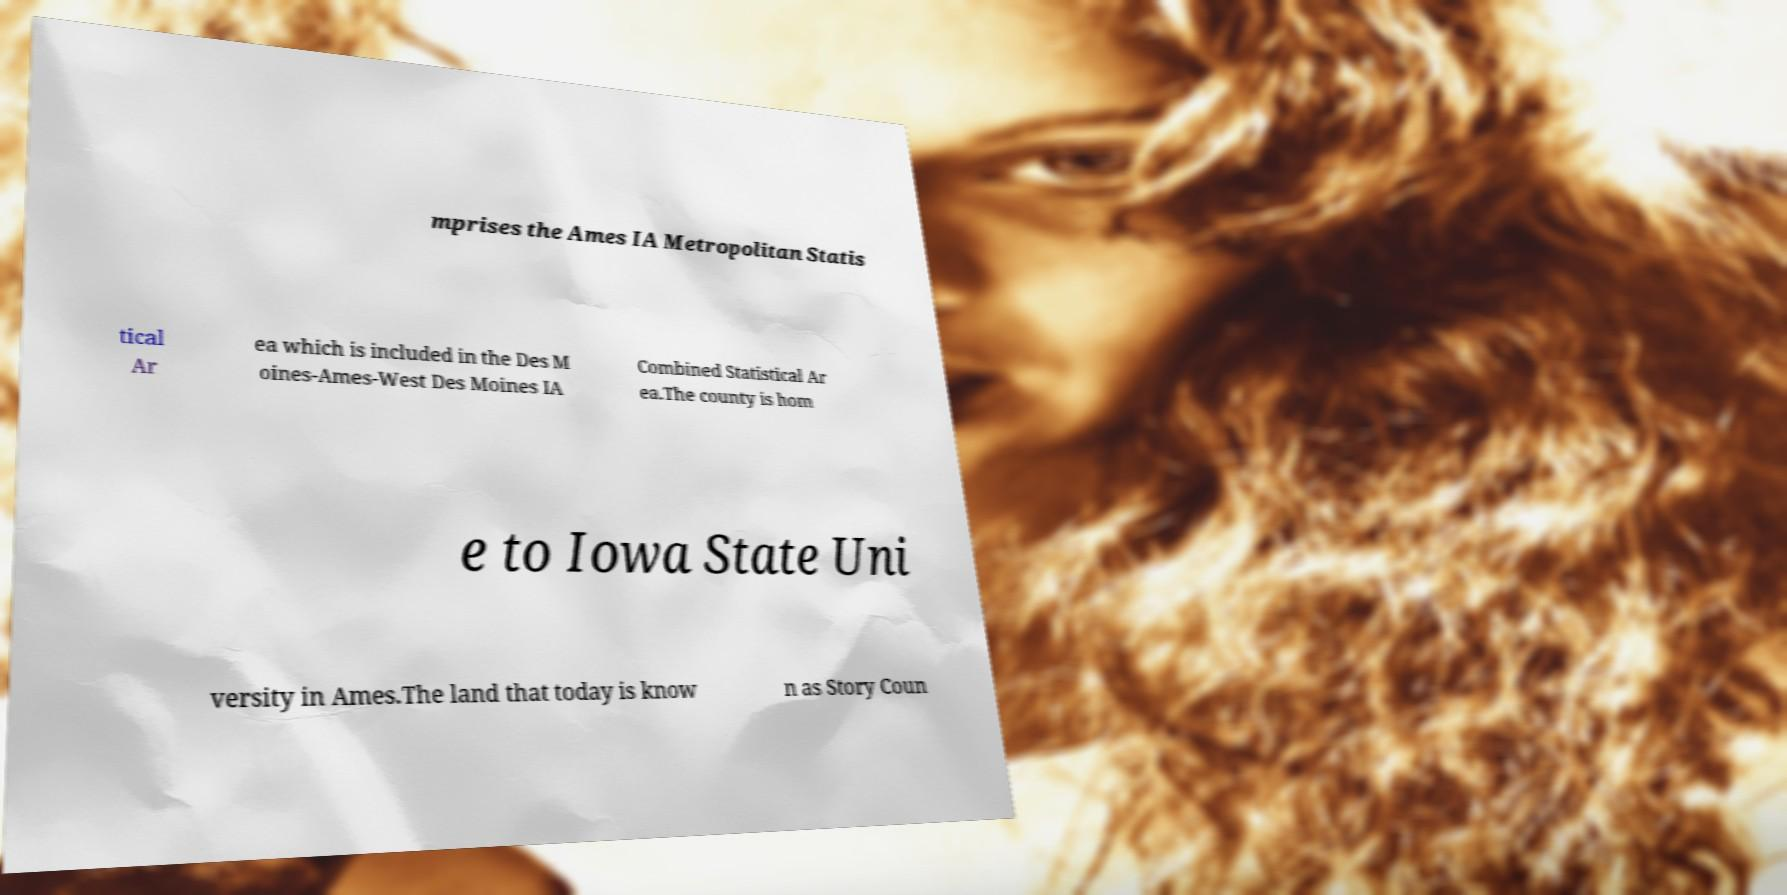Can you accurately transcribe the text from the provided image for me? mprises the Ames IA Metropolitan Statis tical Ar ea which is included in the Des M oines-Ames-West Des Moines IA Combined Statistical Ar ea.The county is hom e to Iowa State Uni versity in Ames.The land that today is know n as Story Coun 